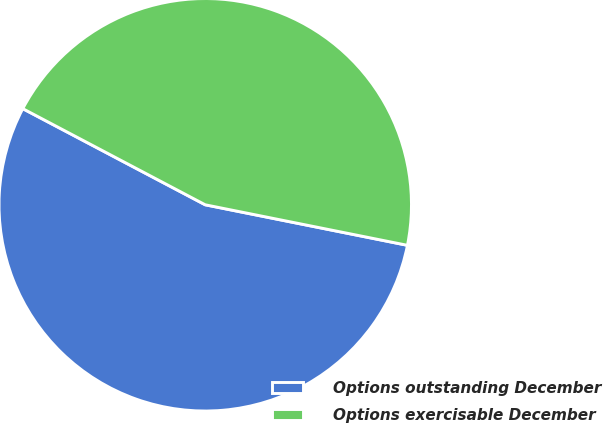Convert chart. <chart><loc_0><loc_0><loc_500><loc_500><pie_chart><fcel>Options outstanding December<fcel>Options exercisable December<nl><fcel>54.57%<fcel>45.43%<nl></chart> 